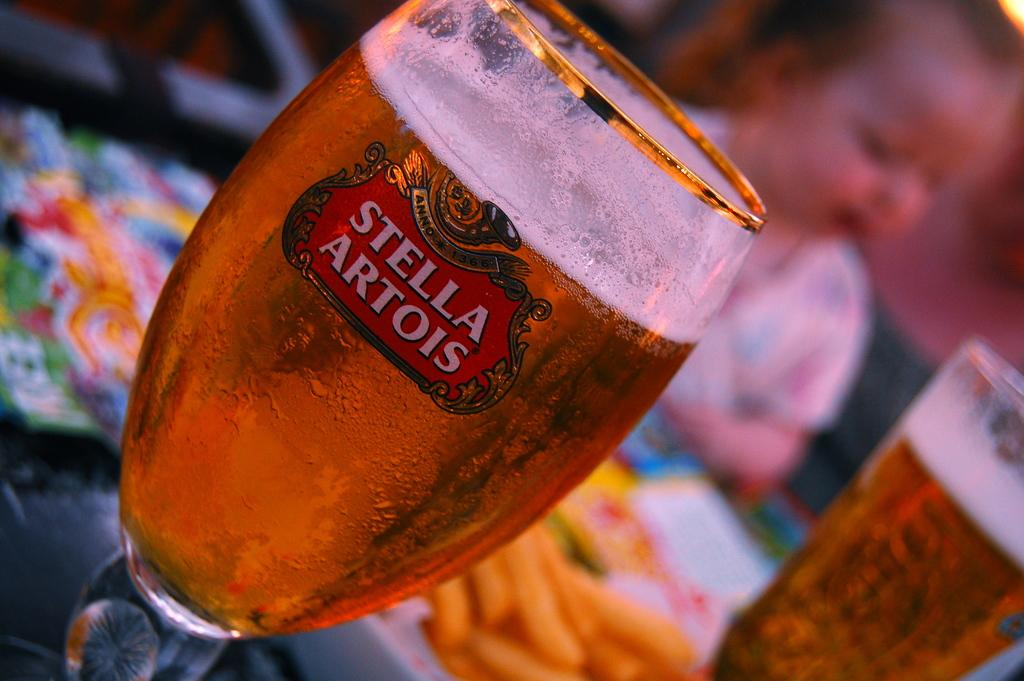<image>
Offer a succinct explanation of the picture presented. A glass sits on a table full of Stella Artois beer. 